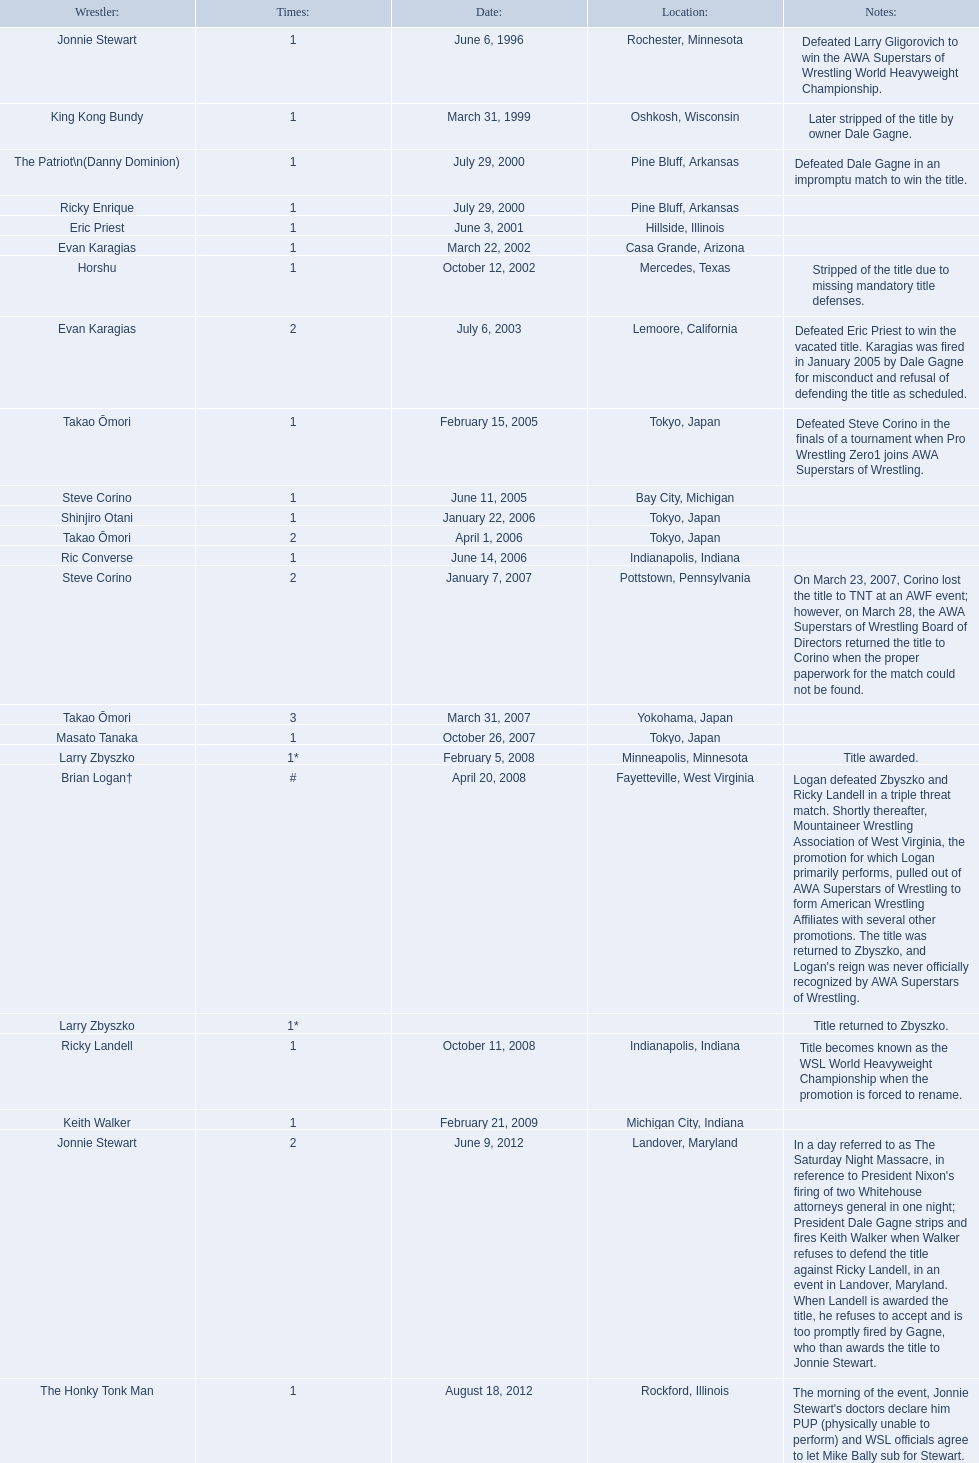Where do the title owners come from? Rochester, Minnesota, Oshkosh, Wisconsin, Pine Bluff, Arkansas, Pine Bluff, Arkansas, Hillside, Illinois, Casa Grande, Arizona, Mercedes, Texas, Lemoore, California, Tokyo, Japan, Bay City, Michigan, Tokyo, Japan, Tokyo, Japan, Indianapolis, Indiana, Pottstown, Pennsylvania, Yokohama, Japan, Tokyo, Japan, Minneapolis, Minnesota, Fayetteville, West Virginia, , Indianapolis, Indiana, Michigan City, Indiana, Landover, Maryland, Rockford, Illinois. Who is the title owner from texas? Horshu. 